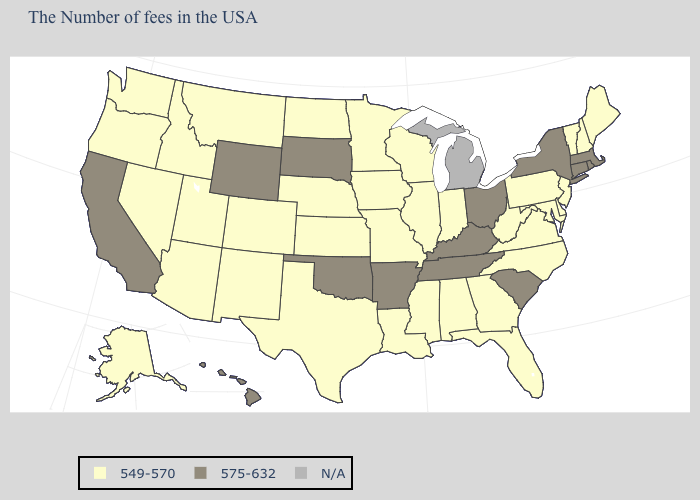Name the states that have a value in the range 549-570?
Keep it brief. Maine, New Hampshire, Vermont, New Jersey, Delaware, Maryland, Pennsylvania, Virginia, North Carolina, West Virginia, Florida, Georgia, Indiana, Alabama, Wisconsin, Illinois, Mississippi, Louisiana, Missouri, Minnesota, Iowa, Kansas, Nebraska, Texas, North Dakota, Colorado, New Mexico, Utah, Montana, Arizona, Idaho, Nevada, Washington, Oregon, Alaska. Does the first symbol in the legend represent the smallest category?
Quick response, please. Yes. Among the states that border South Carolina , which have the highest value?
Be succinct. North Carolina, Georgia. Is the legend a continuous bar?
Concise answer only. No. What is the highest value in the Northeast ?
Concise answer only. 575-632. What is the lowest value in states that border Delaware?
Answer briefly. 549-570. Among the states that border Arkansas , which have the lowest value?
Be succinct. Mississippi, Louisiana, Missouri, Texas. Which states have the lowest value in the USA?
Quick response, please. Maine, New Hampshire, Vermont, New Jersey, Delaware, Maryland, Pennsylvania, Virginia, North Carolina, West Virginia, Florida, Georgia, Indiana, Alabama, Wisconsin, Illinois, Mississippi, Louisiana, Missouri, Minnesota, Iowa, Kansas, Nebraska, Texas, North Dakota, Colorado, New Mexico, Utah, Montana, Arizona, Idaho, Nevada, Washington, Oregon, Alaska. Does California have the lowest value in the USA?
Short answer required. No. Name the states that have a value in the range 575-632?
Write a very short answer. Massachusetts, Rhode Island, Connecticut, New York, South Carolina, Ohio, Kentucky, Tennessee, Arkansas, Oklahoma, South Dakota, Wyoming, California, Hawaii. What is the value of Iowa?
Concise answer only. 549-570. What is the highest value in the West ?
Write a very short answer. 575-632. Which states have the lowest value in the USA?
Give a very brief answer. Maine, New Hampshire, Vermont, New Jersey, Delaware, Maryland, Pennsylvania, Virginia, North Carolina, West Virginia, Florida, Georgia, Indiana, Alabama, Wisconsin, Illinois, Mississippi, Louisiana, Missouri, Minnesota, Iowa, Kansas, Nebraska, Texas, North Dakota, Colorado, New Mexico, Utah, Montana, Arizona, Idaho, Nevada, Washington, Oregon, Alaska. What is the value of Oregon?
Write a very short answer. 549-570. 